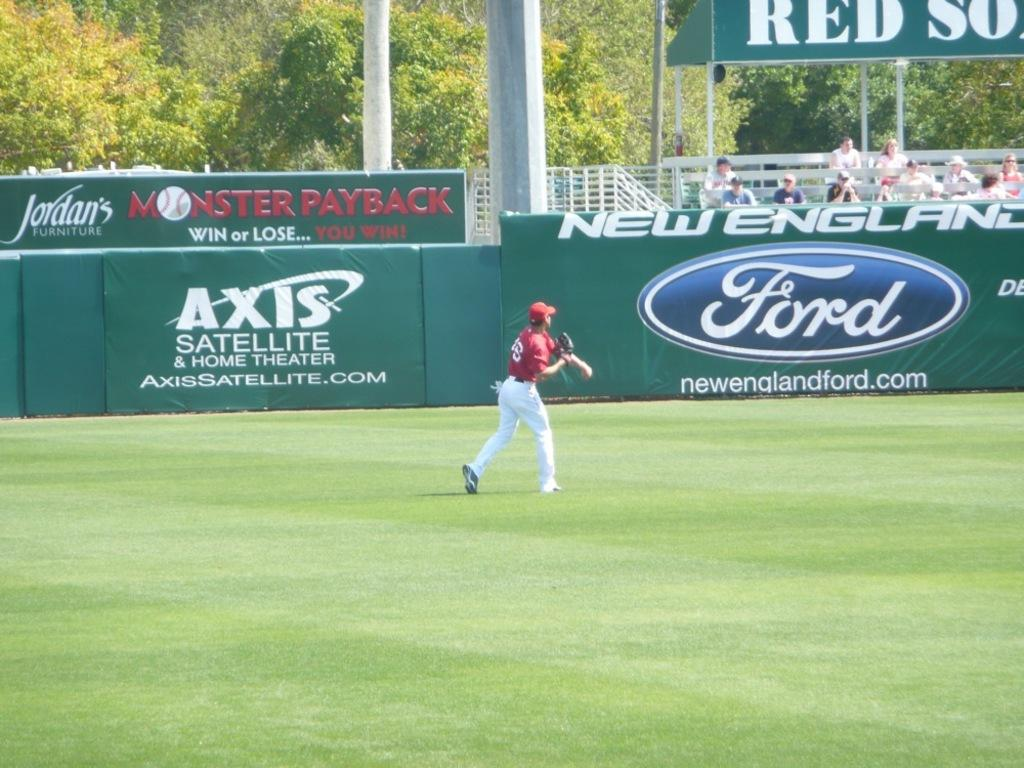<image>
Create a compact narrative representing the image presented. An outfielder going for a ball with Ford and Axis Satellite advertisements in front of him. 